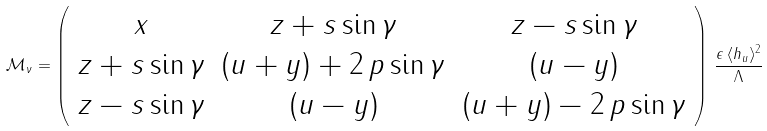Convert formula to latex. <formula><loc_0><loc_0><loc_500><loc_500>\mathcal { M } _ { \nu } = \left ( \begin{array} { c c c } x & z + s \sin \gamma & z - s \sin \gamma \\ z + s \sin \gamma & ( u + y ) + 2 \, p \sin \gamma & ( u - y ) \\ z - s \sin \gamma & ( u - y ) & ( u + y ) - 2 \, p \sin \gamma \end{array} \right ) \, \frac { \epsilon \, \langle h _ { u } \rangle ^ { 2 } } { \Lambda }</formula> 